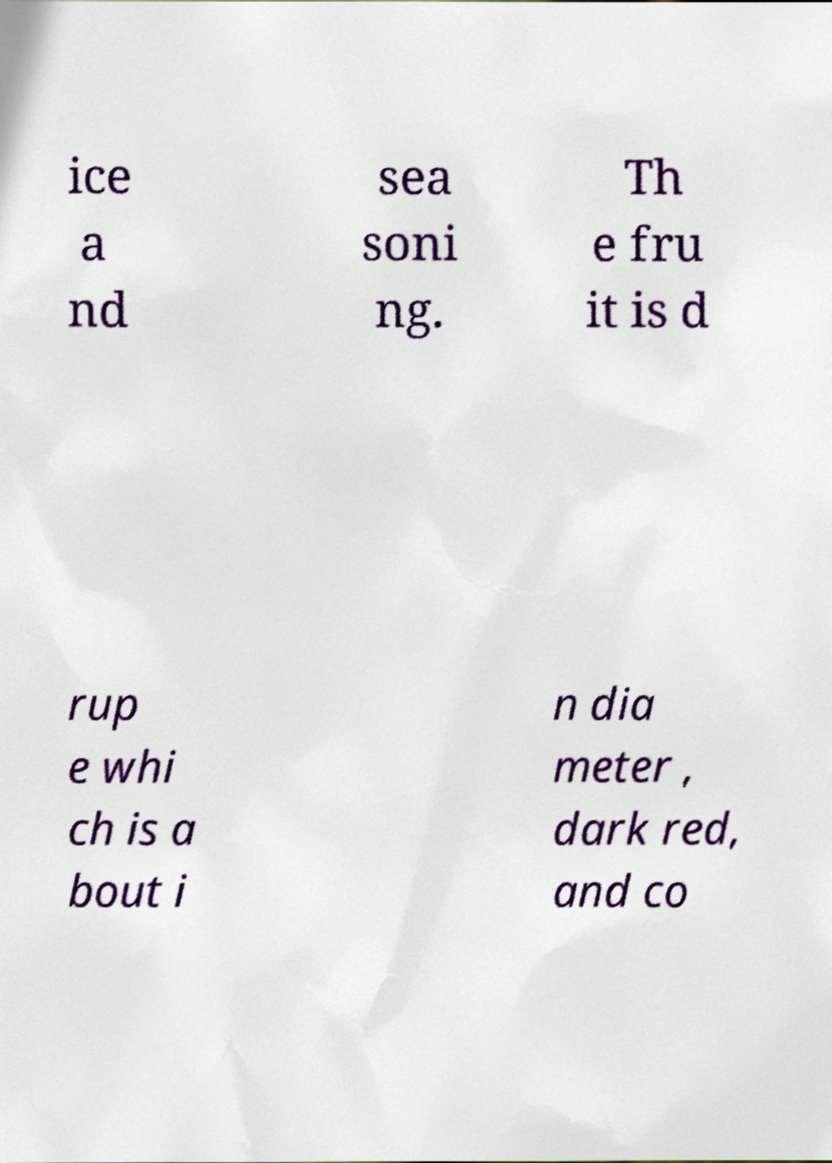Please identify and transcribe the text found in this image. ice a nd sea soni ng. Th e fru it is d rup e whi ch is a bout i n dia meter , dark red, and co 